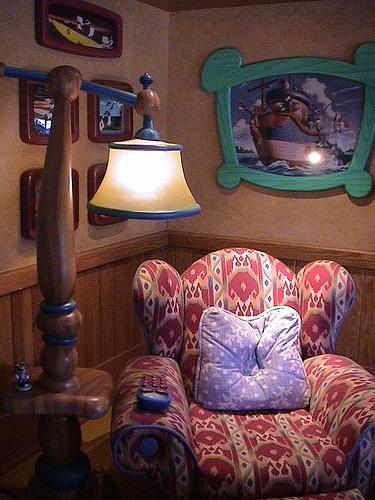Is this a cute house?
Keep it brief. Yes. Is the light on?
Keep it brief. Yes. Where is the remote?
Concise answer only. Chair arm. 